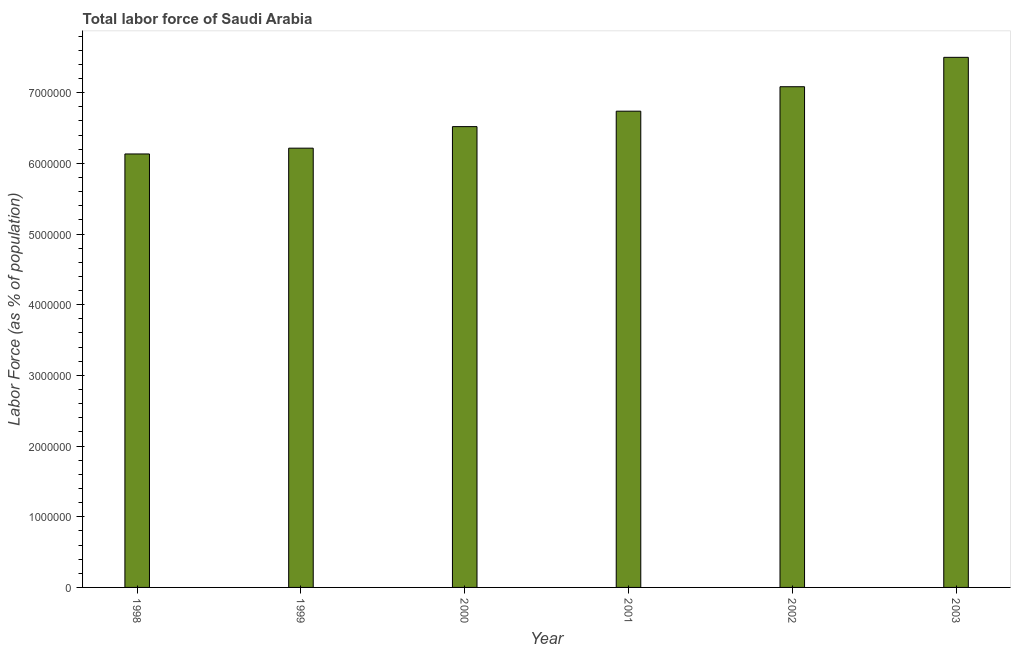What is the title of the graph?
Your response must be concise. Total labor force of Saudi Arabia. What is the label or title of the X-axis?
Provide a short and direct response. Year. What is the label or title of the Y-axis?
Provide a short and direct response. Labor Force (as % of population). What is the total labor force in 2001?
Give a very brief answer. 6.74e+06. Across all years, what is the maximum total labor force?
Your response must be concise. 7.50e+06. Across all years, what is the minimum total labor force?
Your answer should be very brief. 6.13e+06. What is the sum of the total labor force?
Offer a very short reply. 4.02e+07. What is the difference between the total labor force in 1999 and 2001?
Provide a succinct answer. -5.23e+05. What is the average total labor force per year?
Provide a succinct answer. 6.70e+06. What is the median total labor force?
Ensure brevity in your answer.  6.63e+06. What is the ratio of the total labor force in 2001 to that in 2003?
Your answer should be compact. 0.9. What is the difference between the highest and the second highest total labor force?
Keep it short and to the point. 4.16e+05. Is the sum of the total labor force in 1998 and 2003 greater than the maximum total labor force across all years?
Make the answer very short. Yes. What is the difference between the highest and the lowest total labor force?
Give a very brief answer. 1.37e+06. How many bars are there?
Make the answer very short. 6. Are all the bars in the graph horizontal?
Your answer should be compact. No. How many years are there in the graph?
Offer a terse response. 6. What is the difference between two consecutive major ticks on the Y-axis?
Your answer should be very brief. 1.00e+06. Are the values on the major ticks of Y-axis written in scientific E-notation?
Ensure brevity in your answer.  No. What is the Labor Force (as % of population) of 1998?
Offer a very short reply. 6.13e+06. What is the Labor Force (as % of population) of 1999?
Give a very brief answer. 6.21e+06. What is the Labor Force (as % of population) of 2000?
Provide a succinct answer. 6.52e+06. What is the Labor Force (as % of population) of 2001?
Provide a succinct answer. 6.74e+06. What is the Labor Force (as % of population) of 2002?
Your answer should be compact. 7.08e+06. What is the Labor Force (as % of population) in 2003?
Ensure brevity in your answer.  7.50e+06. What is the difference between the Labor Force (as % of population) in 1998 and 1999?
Keep it short and to the point. -8.19e+04. What is the difference between the Labor Force (as % of population) in 1998 and 2000?
Provide a short and direct response. -3.87e+05. What is the difference between the Labor Force (as % of population) in 1998 and 2001?
Provide a succinct answer. -6.05e+05. What is the difference between the Labor Force (as % of population) in 1998 and 2002?
Keep it short and to the point. -9.51e+05. What is the difference between the Labor Force (as % of population) in 1998 and 2003?
Keep it short and to the point. -1.37e+06. What is the difference between the Labor Force (as % of population) in 1999 and 2000?
Make the answer very short. -3.05e+05. What is the difference between the Labor Force (as % of population) in 1999 and 2001?
Keep it short and to the point. -5.23e+05. What is the difference between the Labor Force (as % of population) in 1999 and 2002?
Offer a very short reply. -8.69e+05. What is the difference between the Labor Force (as % of population) in 1999 and 2003?
Offer a very short reply. -1.29e+06. What is the difference between the Labor Force (as % of population) in 2000 and 2001?
Your response must be concise. -2.18e+05. What is the difference between the Labor Force (as % of population) in 2000 and 2002?
Provide a succinct answer. -5.64e+05. What is the difference between the Labor Force (as % of population) in 2000 and 2003?
Keep it short and to the point. -9.80e+05. What is the difference between the Labor Force (as % of population) in 2001 and 2002?
Make the answer very short. -3.46e+05. What is the difference between the Labor Force (as % of population) in 2001 and 2003?
Ensure brevity in your answer.  -7.62e+05. What is the difference between the Labor Force (as % of population) in 2002 and 2003?
Ensure brevity in your answer.  -4.16e+05. What is the ratio of the Labor Force (as % of population) in 1998 to that in 2000?
Keep it short and to the point. 0.94. What is the ratio of the Labor Force (as % of population) in 1998 to that in 2001?
Your response must be concise. 0.91. What is the ratio of the Labor Force (as % of population) in 1998 to that in 2002?
Your response must be concise. 0.87. What is the ratio of the Labor Force (as % of population) in 1998 to that in 2003?
Your answer should be compact. 0.82. What is the ratio of the Labor Force (as % of population) in 1999 to that in 2000?
Your answer should be compact. 0.95. What is the ratio of the Labor Force (as % of population) in 1999 to that in 2001?
Provide a short and direct response. 0.92. What is the ratio of the Labor Force (as % of population) in 1999 to that in 2002?
Offer a very short reply. 0.88. What is the ratio of the Labor Force (as % of population) in 1999 to that in 2003?
Your answer should be compact. 0.83. What is the ratio of the Labor Force (as % of population) in 2000 to that in 2001?
Provide a succinct answer. 0.97. What is the ratio of the Labor Force (as % of population) in 2000 to that in 2003?
Your answer should be very brief. 0.87. What is the ratio of the Labor Force (as % of population) in 2001 to that in 2002?
Ensure brevity in your answer.  0.95. What is the ratio of the Labor Force (as % of population) in 2001 to that in 2003?
Offer a terse response. 0.9. What is the ratio of the Labor Force (as % of population) in 2002 to that in 2003?
Keep it short and to the point. 0.94. 